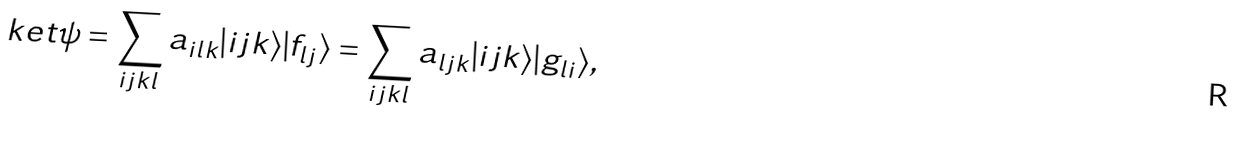<formula> <loc_0><loc_0><loc_500><loc_500>\ k e t \psi = \sum _ { i j k l } a _ { i l k } | i j k \rangle | f _ { l j } \rangle = \sum _ { i j k l } a _ { l j k } | i j k \rangle | g _ { l i } \rangle ,</formula> 